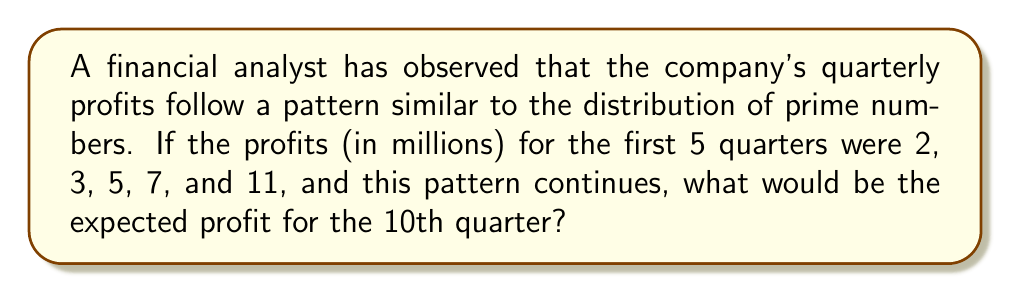Show me your answer to this math problem. To solve this problem, we need to follow these steps:

1. Recognize the pattern: The given profits correspond to the first five prime numbers.

2. Extend the sequence of prime numbers:
   - 1st prime: 2
   - 2nd prime: 3
   - 3rd prime: 5
   - 4th prime: 7
   - 5th prime: 11
   - 6th prime: 13
   - 7th prime: 17
   - 8th prime: 19
   - 9th prime: 23
   - 10th prime: 29

3. Identify the 10th prime number: 29

4. Conclude that if the pattern continues, the profit for the 10th quarter would be $29 million.

This analysis demonstrates how prime number distribution can be used to predict financial trends, albeit in a simplified manner. In reality, financial trends are much more complex and influenced by numerous factors beyond mathematical sequences.
Answer: $29 million 